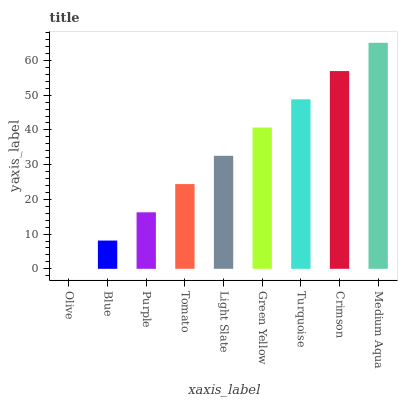Is Blue the minimum?
Answer yes or no. No. Is Blue the maximum?
Answer yes or no. No. Is Blue greater than Olive?
Answer yes or no. Yes. Is Olive less than Blue?
Answer yes or no. Yes. Is Olive greater than Blue?
Answer yes or no. No. Is Blue less than Olive?
Answer yes or no. No. Is Light Slate the high median?
Answer yes or no. Yes. Is Light Slate the low median?
Answer yes or no. Yes. Is Green Yellow the high median?
Answer yes or no. No. Is Crimson the low median?
Answer yes or no. No. 